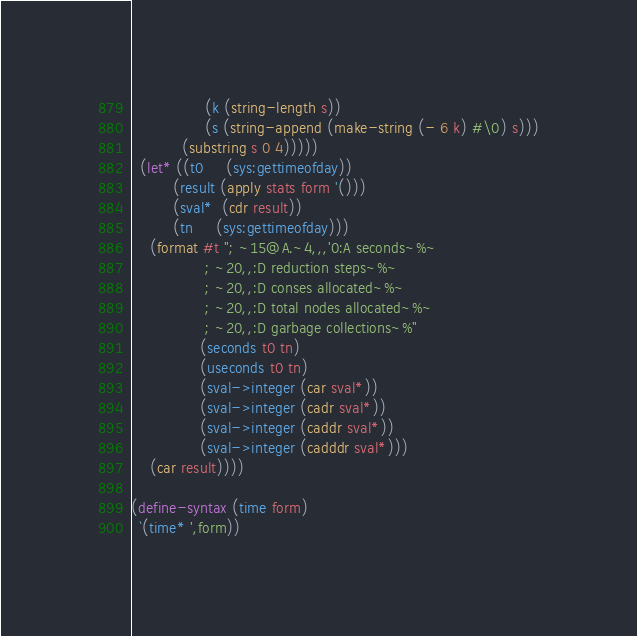<code> <loc_0><loc_0><loc_500><loc_500><_Scheme_>                (k (string-length s))
                (s (string-append (make-string (- 6 k) #\0) s)))
           (substring s 0 4)))))
  (let* ((t0     (sys:gettimeofday))
         (result (apply stats form '()))
         (sval*  (cdr result))
         (tn     (sys:gettimeofday)))
    (format #t "; ~15@A.~4,,,'0:A seconds~%~
                ; ~20,,:D reduction steps~%~
                ; ~20,,:D conses allocated~%~
                ; ~20,,:D total nodes allocated~%~
                ; ~20,,:D garbage collections~%"
               (seconds t0 tn)
               (useconds t0 tn)
               (sval->integer (car sval*))
               (sval->integer (cadr sval*))
               (sval->integer (caddr sval*))
               (sval->integer (cadddr sval*)))
    (car result))))

(define-syntax (time form)
  `(time* ',form))
</code> 